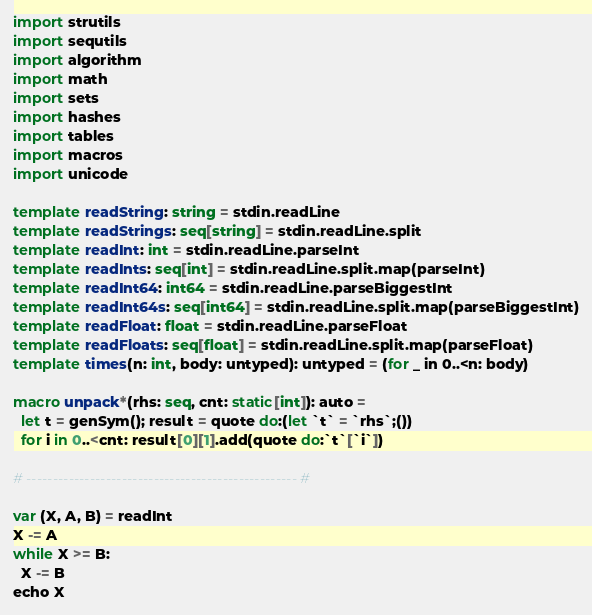Convert code to text. <code><loc_0><loc_0><loc_500><loc_500><_Nim_>import strutils
import sequtils
import algorithm
import math
import sets
import hashes
import tables
import macros
import unicode

template readString: string = stdin.readLine
template readStrings: seq[string] = stdin.readLine.split
template readInt: int = stdin.readLine.parseInt
template readInts: seq[int] = stdin.readLine.split.map(parseInt)
template readInt64: int64 = stdin.readLine.parseBiggestInt
template readInt64s: seq[int64] = stdin.readLine.split.map(parseBiggestInt)
template readFloat: float = stdin.readLine.parseFloat
template readFloats: seq[float] = stdin.readLine.split.map(parseFloat)
template times(n: int, body: untyped): untyped = (for _ in 0..<n: body)

macro unpack*(rhs: seq, cnt: static[int]): auto =
  let t = genSym(); result = quote do:(let `t` = `rhs`;())
  for i in 0..<cnt: result[0][1].add(quote do:`t`[`i`])

# --------------------------------------------------- #

var (X, A, B) = readInt
X -= A
while X >= B:
  X -= B
echo X</code> 